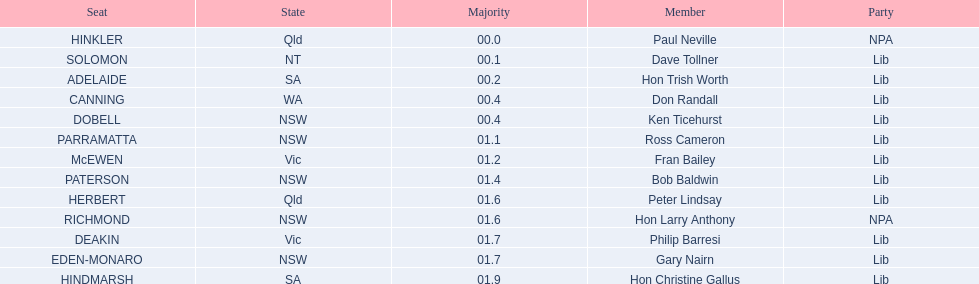Can you list the members of the liberal party? Dave Tollner, Hon Trish Worth, Don Randall, Ken Ticehurst, Ross Cameron, Fran Bailey, Bob Baldwin, Peter Lindsay, Philip Barresi, Gary Nairn, Hon Christine Gallus. Which ones are based in south australia? Hon Trish Worth, Hon Christine Gallus. What is the greatest difference in majority among members in south australia? 01.9. 